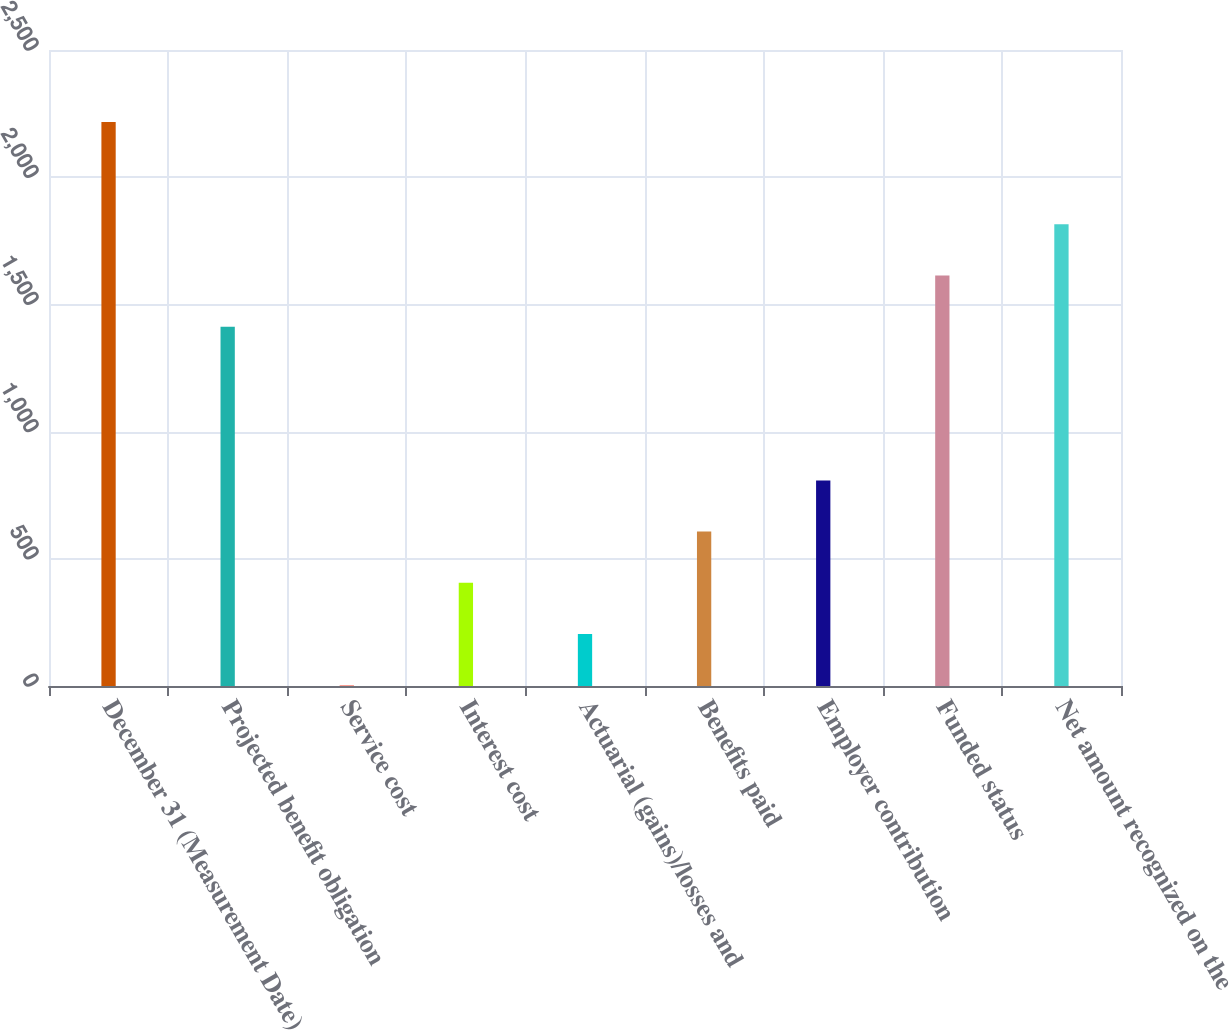<chart> <loc_0><loc_0><loc_500><loc_500><bar_chart><fcel>December 31 (Measurement Date)<fcel>Projected benefit obligation<fcel>Service cost<fcel>Interest cost<fcel>Actuarial (gains)/losses and<fcel>Benefits paid<fcel>Employer contribution<fcel>Funded status<fcel>Net amount recognized on the<nl><fcel>2217.3<fcel>1412.1<fcel>3<fcel>405.6<fcel>204.3<fcel>606.9<fcel>808.2<fcel>1613.4<fcel>1814.7<nl></chart> 